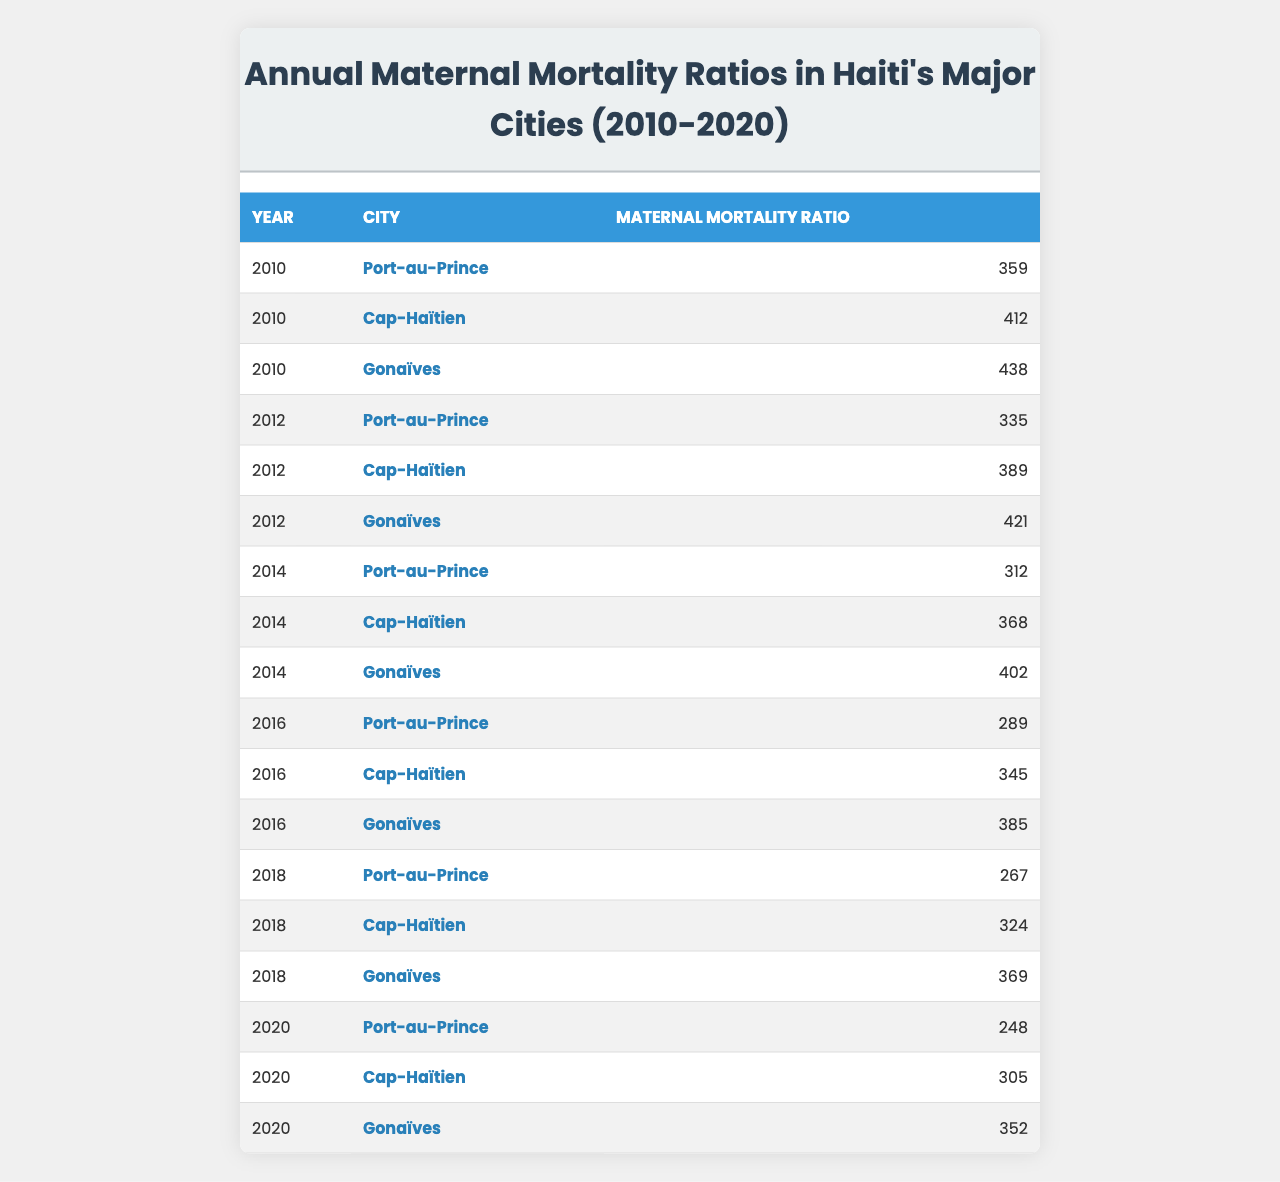What was the maternal mortality ratio in Port-au-Prince in 2010? The table shows that in 2010, the maternal mortality ratio for Port-au-Prince was 359.
Answer: 359 Which city had the highest maternal mortality ratio in 2014? In 2014, the table indicates that Gonaïves had the highest maternal mortality ratio at 402.
Answer: 402 What is the trend in maternal mortality ratios in Port-au-Prince from 2010 to 2020? By comparing the values in the table, we see that the ratios decreased each year from 359 in 2010 to 248 in 2020, showing a downward trend.
Answer: Decreasing trend What were the maternal mortality ratios in Cap-Haïtien for the years 2012 and 2018? According to the table, Cap-Haïtien had ratios of 389 in 2012 and 324 in 2018, showing a decrease.
Answer: 389 and 324 What was the average maternal mortality ratio for Gonaïves from 2010 to 2020? To find the average, sum the ratios for Gonaïves (438 + 421 + 402 + 385 + 369 + 352 = 2267) and divide by 6. This gives an average of 2267 / 6 = 378.5.
Answer: 378.5 Did the maternal mortality ratio in Cap-Haïtien improve from 2010 to 2020? Yes, in 2010 the ratio was 412 and in 2020 it was 305, indicating an improvement over the years.
Answer: Yes Which city experienced the least maternal mortality ratio in 2016? The table shows that Port-au-Prince had the lowest ratio in 2016 at 289 compared to other cities that year.
Answer: 289 What is the difference in maternal mortality ratios between Gonaïves in 2010 and 2020? From the table, the ratio for Gonaïves in 2010 was 438 and in 2020 it was 352. Taking the difference gives 438 - 352 = 86.
Answer: 86 In which year did Cap-Haïtien have a maternal mortality ratio above 400? The table indicates Cap-Haïtien had ratios above 400 in the years 2010 (412) and 2012 (389), but not after 2014.
Answer: 2010 and 2012 What was the maternal mortality ratio of Port-au-Prince in 2018? Referring to the table, the maternal mortality ratio for Port-au-Prince in 2018 was 267.
Answer: 267 